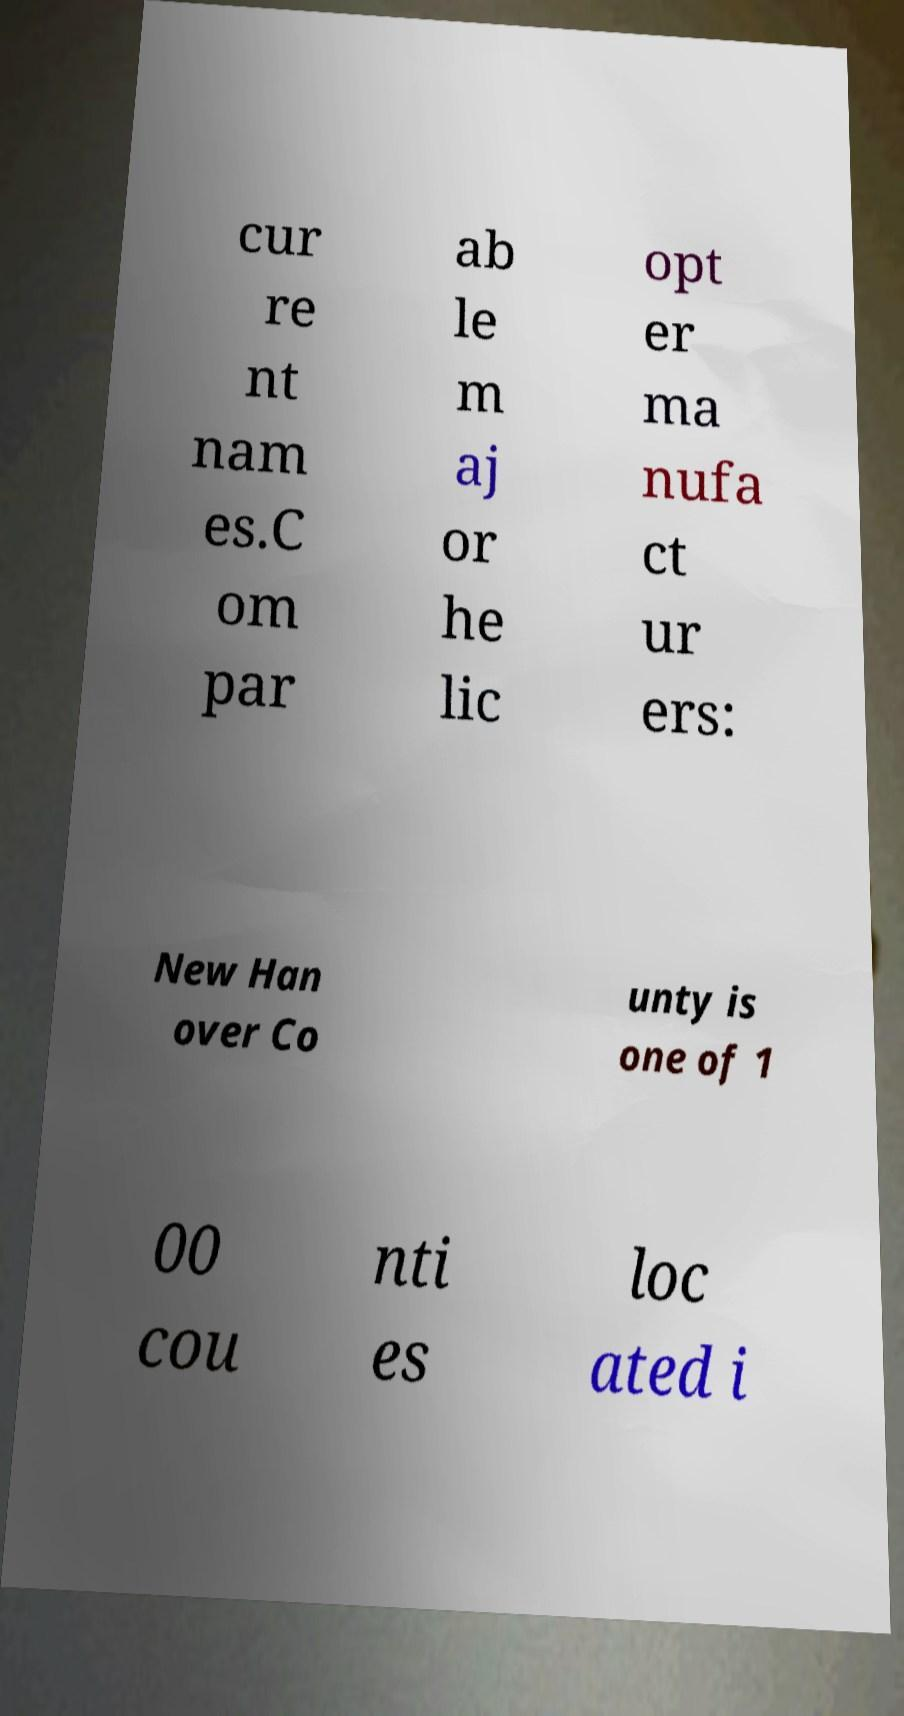Can you accurately transcribe the text from the provided image for me? cur re nt nam es.C om par ab le m aj or he lic opt er ma nufa ct ur ers: New Han over Co unty is one of 1 00 cou nti es loc ated i 